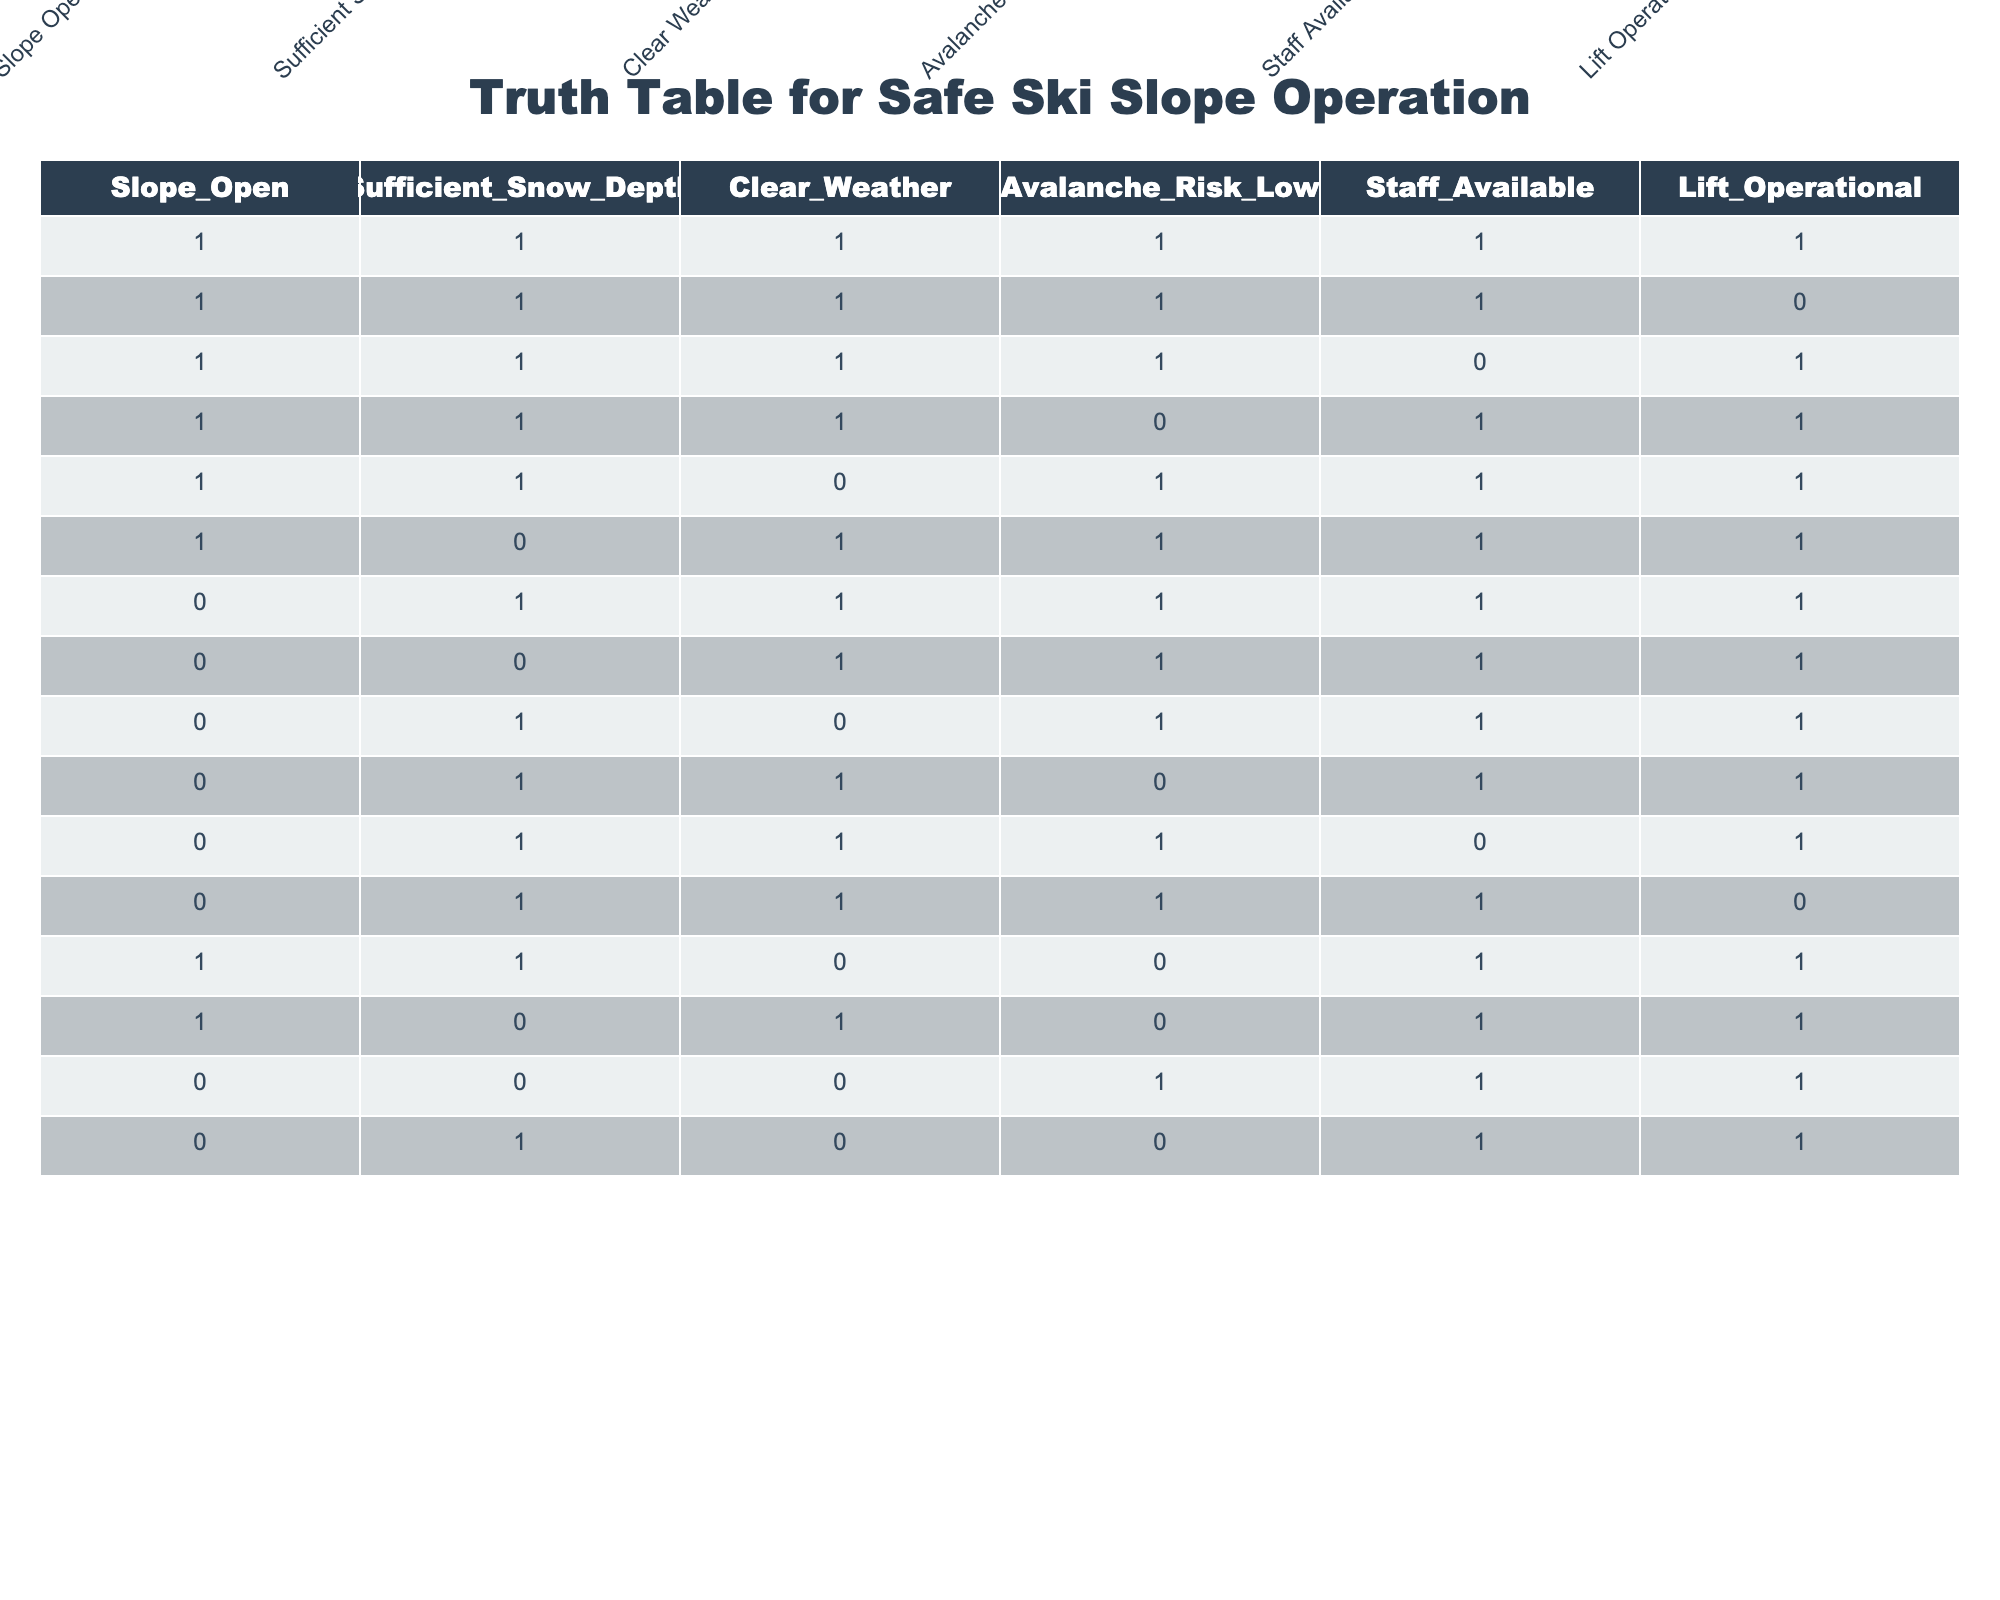What is the total number of rows where the ski slope is open? Count the number of rows where Slope_Open equals 1. There are 8 occurrences of Slope_Open being 1, indicating that the slope is open in those cases.
Answer: 8 How many rows have both Clear Weather and Lift Operational? Check the rows where both Clear_Weather and Lift_Operational are equal to 1. There are 5 rows that meet this criterion.
Answer: 5 Is there any instance where the slope is open and the avalanche risk is high? Look for occurrences where Slope_Open equals 1 and Avalanche_Risk_Low equals 0. There are 3 instances that satisfy these conditions indicating that the slope is open while the avalanche risk is high.
Answer: Yes What percentage of the total entries have sufficient snow depth? There are a total of 16 rows, and we need to count the rows where Sufficient_Snow_Depth is 1. There are 9 such rows. The percentage is (9/16) * 100 = 56.25%.
Answer: 56.25 Consider the case when sufficient snow depth is available and the weather is clear. What is the count of such scenarios where the slope is operational? Identify the rows where Sufficient_Snow_Depth equals 1, Clear_Weather equals 1, and Lift_Operational equals 1. There are 3 such scenarios where all these conditions are met.
Answer: 3 Is there a scenario with sufficient snow depth, clear weather, but lift operational is off? Find rows where Sufficient_Snow_Depth equals 1, Clear_Weather equals 1, and Lift_Operational equals 0. There are no rows meeting these criteria.
Answer: No What is the average number of conditions met for all rows? Count the number of conditions met (1s) for each row and then average those counts across all entries. After calculating, the average is approximately 3.125 conditions met per entry.
Answer: 3.125 How many cases exist where at least one condition (snow depth, weather, avalanche risk, staff, lift) is not met when the slope is open? Count rows where Slope_Open equals 1 and at least one of the conditions (Sufficient_Snow_Depth, Clear_Weather, Avalanche_Risk_Low, Staff_Available, Lift_Operational) is 0. This gives a total of 5 such cases.
Answer: 5 